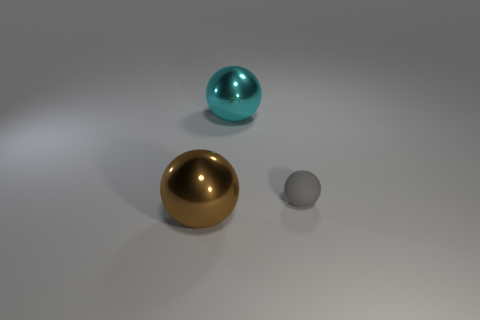Are there any other things that are the same material as the gray sphere?
Provide a short and direct response. No. There is a shiny object behind the gray rubber object; is it the same size as the gray thing?
Your answer should be very brief. No. Is there anything else that has the same size as the gray matte thing?
Ensure brevity in your answer.  No. There is a cyan metal object that is the same shape as the brown object; what is its size?
Offer a terse response. Large. Are there an equal number of small gray things behind the cyan shiny sphere and spheres behind the big brown metallic sphere?
Offer a very short reply. No. There is a cyan metallic thing that is on the left side of the rubber thing; what is its size?
Offer a very short reply. Large. Is the number of metal spheres on the left side of the tiny thing the same as the number of brown metallic spheres?
Offer a terse response. No. Are there any small gray matte spheres on the left side of the gray rubber ball?
Provide a short and direct response. No. There is a matte object; does it have the same shape as the big metallic thing left of the large cyan metal ball?
Make the answer very short. Yes. There is a large object that is made of the same material as the brown sphere; what color is it?
Your response must be concise. Cyan. 